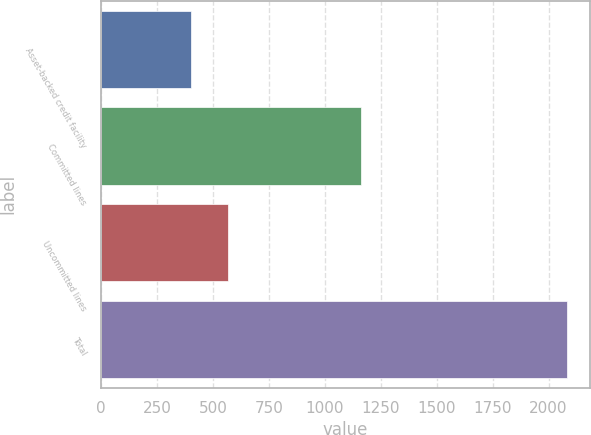<chart> <loc_0><loc_0><loc_500><loc_500><bar_chart><fcel>Asset-backed credit facility<fcel>Committed lines<fcel>Uncommitted lines<fcel>Total<nl><fcel>400<fcel>1161<fcel>568.2<fcel>2082<nl></chart> 